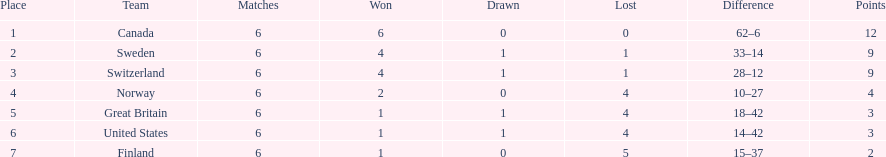What are the country names? Canada, Sweden, Switzerland, Norway, Great Britain, United States, Finland. How many victories did switzerland achieve? 4. How many victories were secured by great britain? 1. Between switzerland and great britain, which one had more wins? Switzerland. 